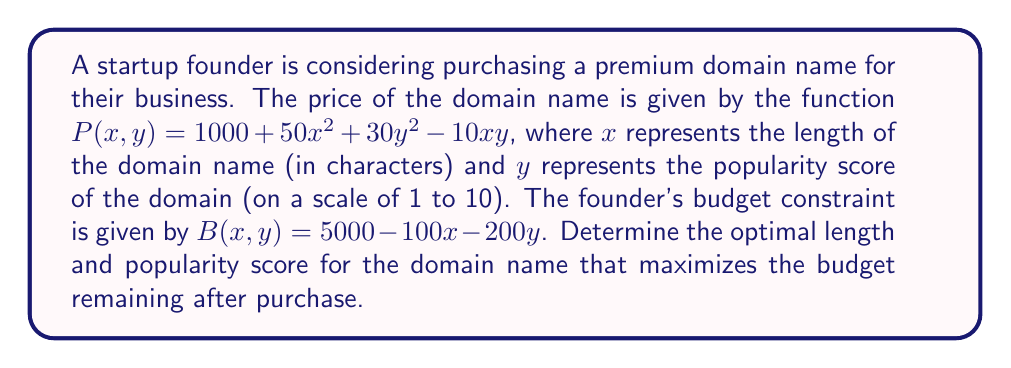Can you solve this math problem? To solve this optimization problem, we need to use the method of Lagrange multipliers:

1. Define the Lagrangian function:
   $$L(x, y, \lambda) = B(x, y) - \lambda(P(x, y) - z)$$
   where $z$ is the price paid for the domain.

2. Substitute the given functions:
   $$L(x, y, \lambda) = (5000 - 100x - 200y) - \lambda(1000 + 50x^2 + 30y^2 - 10xy - z)$$

3. Calculate partial derivatives and set them to zero:
   $$\frac{\partial L}{\partial x} = -100 - \lambda(100x - 10y) = 0$$
   $$\frac{\partial L}{\partial y} = -200 - \lambda(60y - 10x) = 0$$
   $$\frac{\partial L}{\partial \lambda} = -(1000 + 50x^2 + 30y^2 - 10xy - z) = 0$$

4. From the first two equations:
   $$100 + \lambda(100x - 10y) = 0$$
   $$200 + \lambda(60y - 10x) = 0$$

5. Divide the second equation by 2:
   $$100 + \lambda(30y - 5x) = 0$$

6. Equate the results from steps 4 and 5:
   $$100x - 10y = 30y - 5x$$
   $$105x = 40y$$
   $$x = \frac{8y}{21}$$

7. Substitute this into the equation from step 3:
   $$1000 + 50(\frac{8y}{21})^2 + 30y^2 - 10(\frac{8y}{21})y - z = 0$$

8. Simplify:
   $$1000 + \frac{1600y^2}{441} + 30y^2 - \frac{80y^2}{21} - z = 0$$
   $$1000 + \frac{1600y^2 + 13230y^2 - 1680y^2}{441} - z = 0$$
   $$1000 + \frac{13150y^2}{441} - z = 0$$

9. Solve for $z$:
   $$z = 1000 + \frac{13150y^2}{441}$$

10. The budget remaining after purchase is:
    $$5000 - 100(\frac{8y}{21}) - 200y - (1000 + \frac{13150y^2}{441})$$

11. Simplify:
    $$4000 - \frac{3800y + 13150y^2}{441}$$

12. To maximize this, differentiate with respect to $y$ and set to zero:
    $$-\frac{3800 + 26300y}{441} = 0$$
    $$26300y = -3800$$
    $$y = -\frac{19}{131} \approx -0.145$$

13. Since $y$ represents a popularity score and must be positive, the optimal $y$ is at the lower bound of the given range, which is 1.

14. Substitute $y = 1$ back into the equation for $x$:
    $$x = \frac{8(1)}{21} \approx 0.381$$

15. Round $x$ up to the nearest integer, as domain length must be a whole number:
    $$x = 1$$

Therefore, the optimal domain name has a length of 1 character and a popularity score of 1.
Answer: $x = 1$, $y = 1$ 